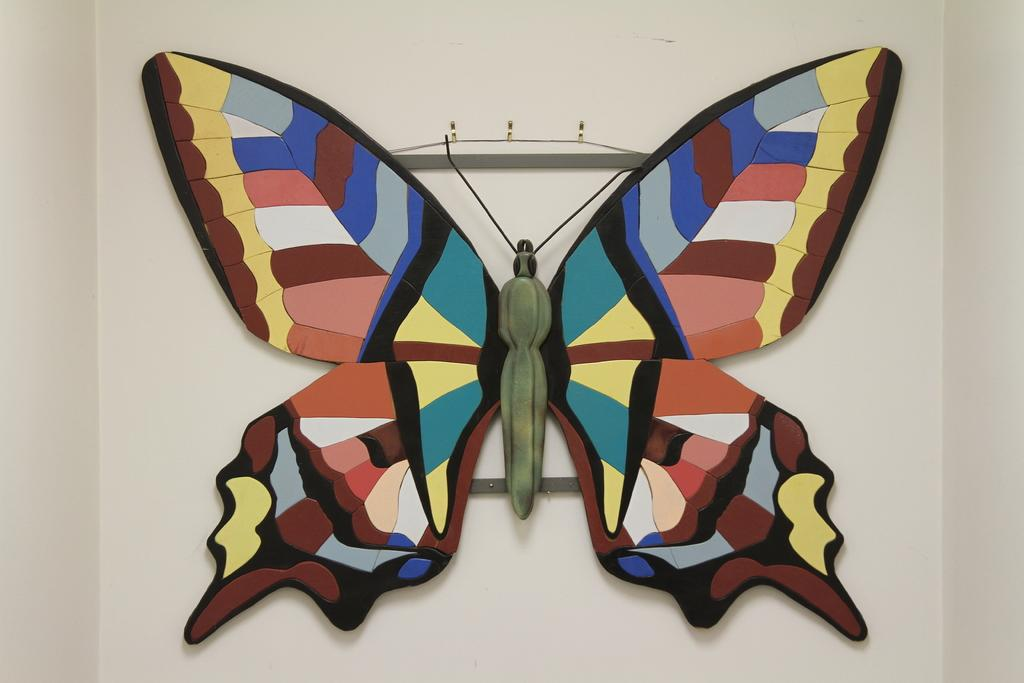What is the main subject of the image? The main subject of the image is a butterfly showpiece. Where is the butterfly showpiece located? The butterfly showpiece is placed on the wall. What colors can be seen on the butterfly? The butterfly has green, yellow, blue, black, and pink colors. What can be seen in the background of the image? There is a wall visible in the background of the image. How many pizzas are being served on the cart in the image? There is no cart or pizza present in the image; it features a butterfly showpiece on the wall. What type of yoke is attached to the butterfly in the image? There is no yoke attached to the butterfly in the image; it is a stationary showpiece. 